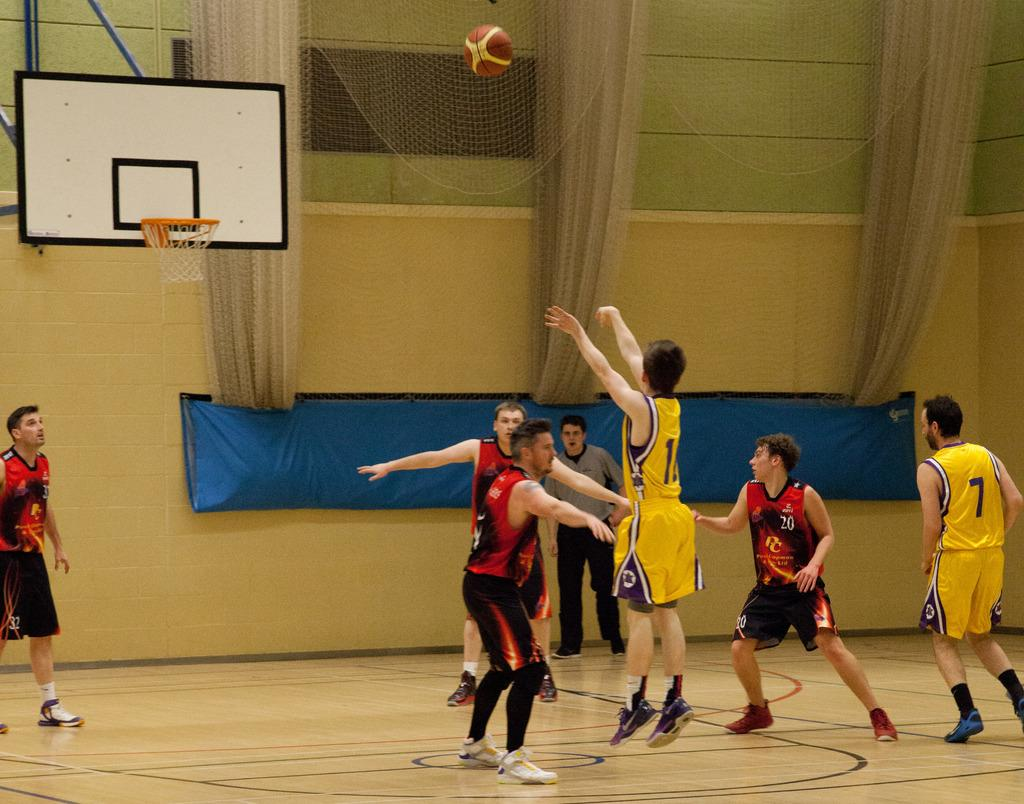<image>
Create a compact narrative representing the image presented. Player seven watches as his teammate shoots the ball. 